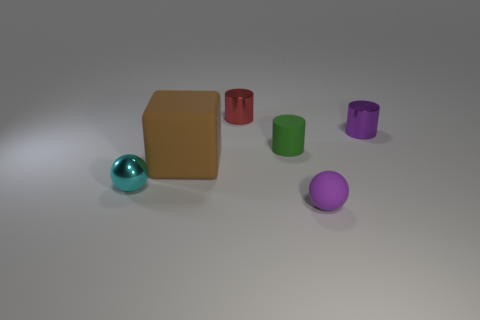The metal cylinder that is the same color as the small rubber ball is what size?
Your response must be concise. Small. Is the number of cyan metallic objects that are left of the large matte object less than the number of spheres to the left of the small purple shiny cylinder?
Provide a short and direct response. Yes. Are there any other things that are the same color as the block?
Ensure brevity in your answer.  No. What is the shape of the large rubber thing?
Your response must be concise. Cube. There is a small ball that is made of the same material as the brown thing; what color is it?
Keep it short and to the point. Purple. Are there more large blue metal balls than cyan objects?
Provide a short and direct response. No. Is there a small cyan matte sphere?
Offer a very short reply. No. What shape is the thing that is to the left of the matte object that is to the left of the tiny red shiny cylinder?
Your answer should be very brief. Sphere. How many objects are large purple blocks or tiny cylinders to the right of the tiny red metallic cylinder?
Your answer should be very brief. 2. What color is the tiny shiny thing that is to the right of the small cylinder behind the purple thing behind the brown object?
Provide a short and direct response. Purple. 